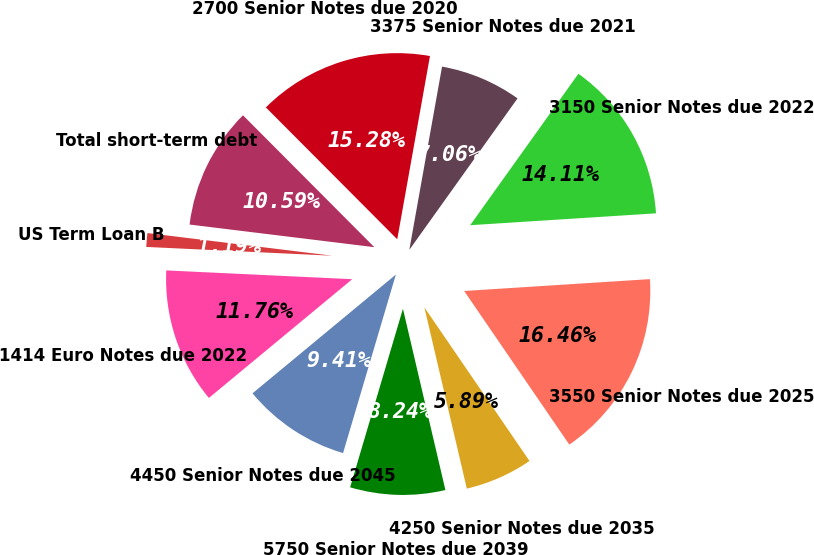Convert chart to OTSL. <chart><loc_0><loc_0><loc_500><loc_500><pie_chart><fcel>US Term Loan B<fcel>Total short-term debt<fcel>2700 Senior Notes due 2020<fcel>3375 Senior Notes due 2021<fcel>3150 Senior Notes due 2022<fcel>3550 Senior Notes due 2025<fcel>4250 Senior Notes due 2035<fcel>5750 Senior Notes due 2039<fcel>4450 Senior Notes due 2045<fcel>1414 Euro Notes due 2022<nl><fcel>1.19%<fcel>10.59%<fcel>15.28%<fcel>7.06%<fcel>14.11%<fcel>16.46%<fcel>5.89%<fcel>8.24%<fcel>9.41%<fcel>11.76%<nl></chart> 